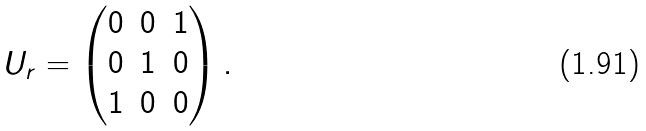Convert formula to latex. <formula><loc_0><loc_0><loc_500><loc_500>U _ { r } = \begin{pmatrix} 0 & 0 & 1 \\ 0 & 1 & 0 \\ 1 & 0 & 0 \end{pmatrix} .</formula> 